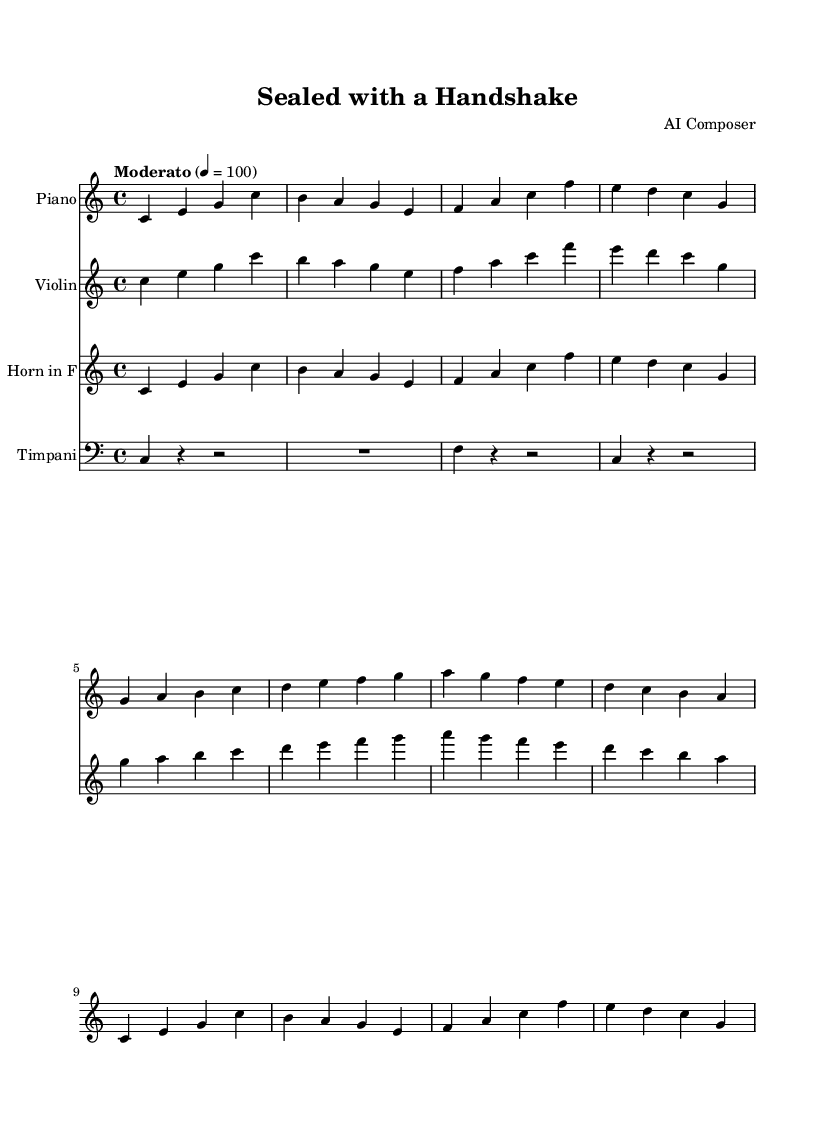What is the key signature of this music? The key signature is C major, which has no sharps or flats.
Answer: C major What is the time signature of this piece? The time signature, indicated at the beginning of the sheet music, shows that the piece is in 4/4 time, meaning there are four beats per measure.
Answer: 4/4 What is the tempo marking of this score? The tempo marking states "Moderato" with a metronome marking of 100 beats per minute, indicating a moderate speed for the piece.
Answer: Moderato Which instrument is transposed, and to what key? The French horn is transposed to F, meaning it plays a perfect fifth lower than the written pitch.
Answer: F How many measures does the piano part contain? By counting the notated measures in the piano part, we find that it contains 8 measures total.
Answer: 8 What emotion or theme does this soundtrack primarily depict? Given the title "Sealed with a Handshake," it suggests a positive and triumphant theme related to successful negotiations or business deals.
Answer: Positive What is the main melodic device used in this score? The score mainly uses arpeggios, which are broken chords played in succession, creating a flowing texture characteristic of cinematic soundtracks.
Answer: Arpeggios 